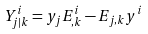<formula> <loc_0><loc_0><loc_500><loc_500>Y ^ { i } _ { j | k } = y _ { j } E ^ { i } _ { , k } - E _ { j , k } y ^ { i }</formula> 